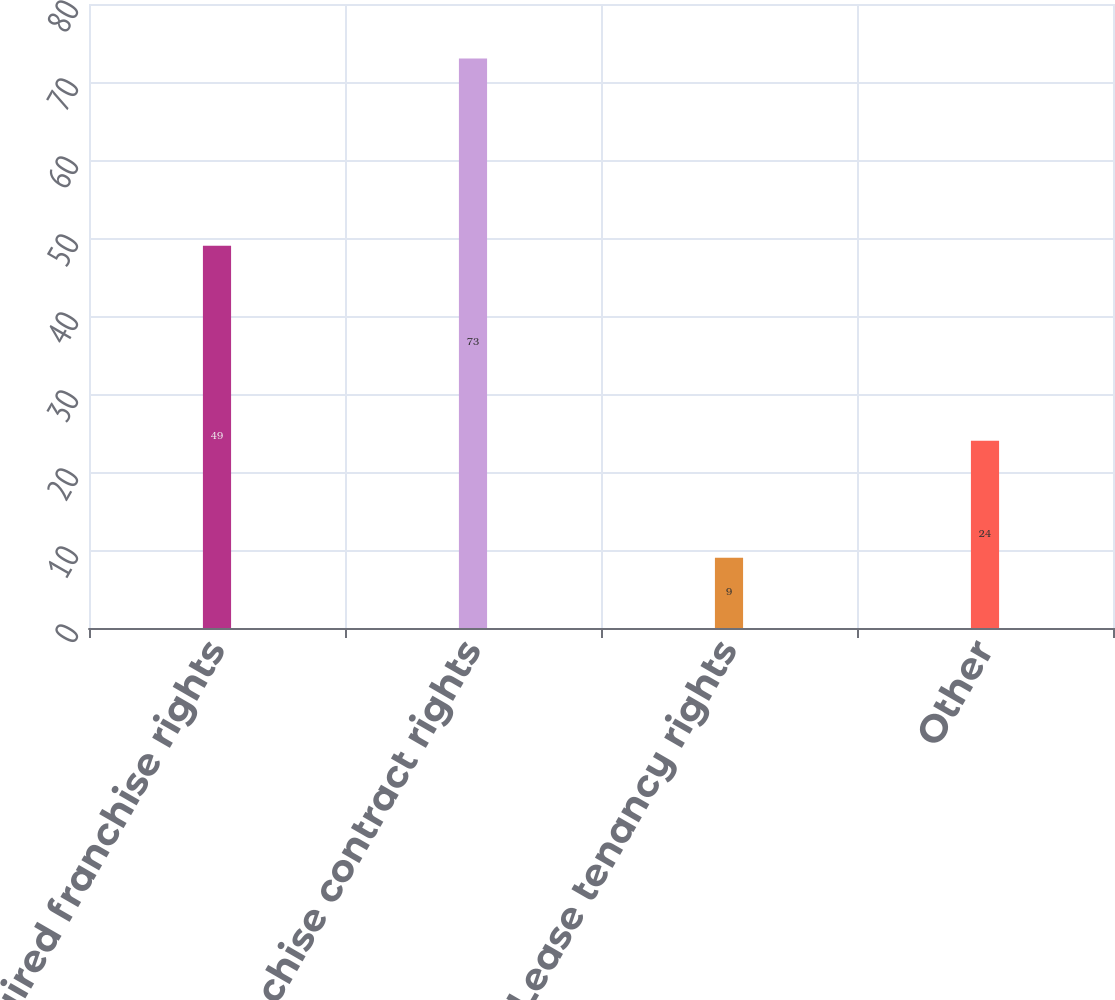<chart> <loc_0><loc_0><loc_500><loc_500><bar_chart><fcel>Reacquired franchise rights<fcel>Franchise contract rights<fcel>Lease tenancy rights<fcel>Other<nl><fcel>49<fcel>73<fcel>9<fcel>24<nl></chart> 